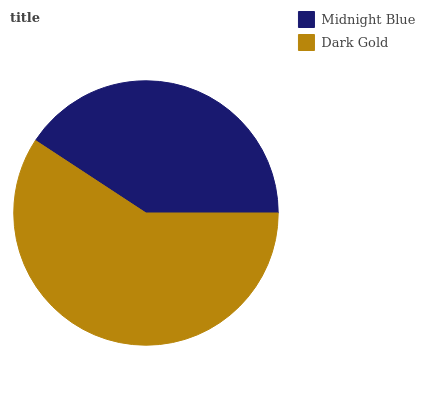Is Midnight Blue the minimum?
Answer yes or no. Yes. Is Dark Gold the maximum?
Answer yes or no. Yes. Is Dark Gold the minimum?
Answer yes or no. No. Is Dark Gold greater than Midnight Blue?
Answer yes or no. Yes. Is Midnight Blue less than Dark Gold?
Answer yes or no. Yes. Is Midnight Blue greater than Dark Gold?
Answer yes or no. No. Is Dark Gold less than Midnight Blue?
Answer yes or no. No. Is Dark Gold the high median?
Answer yes or no. Yes. Is Midnight Blue the low median?
Answer yes or no. Yes. Is Midnight Blue the high median?
Answer yes or no. No. Is Dark Gold the low median?
Answer yes or no. No. 